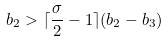<formula> <loc_0><loc_0><loc_500><loc_500>b _ { 2 } > \lceil \frac { \sigma } { 2 } - 1 \rceil ( b _ { 2 } - b _ { 3 } )</formula> 